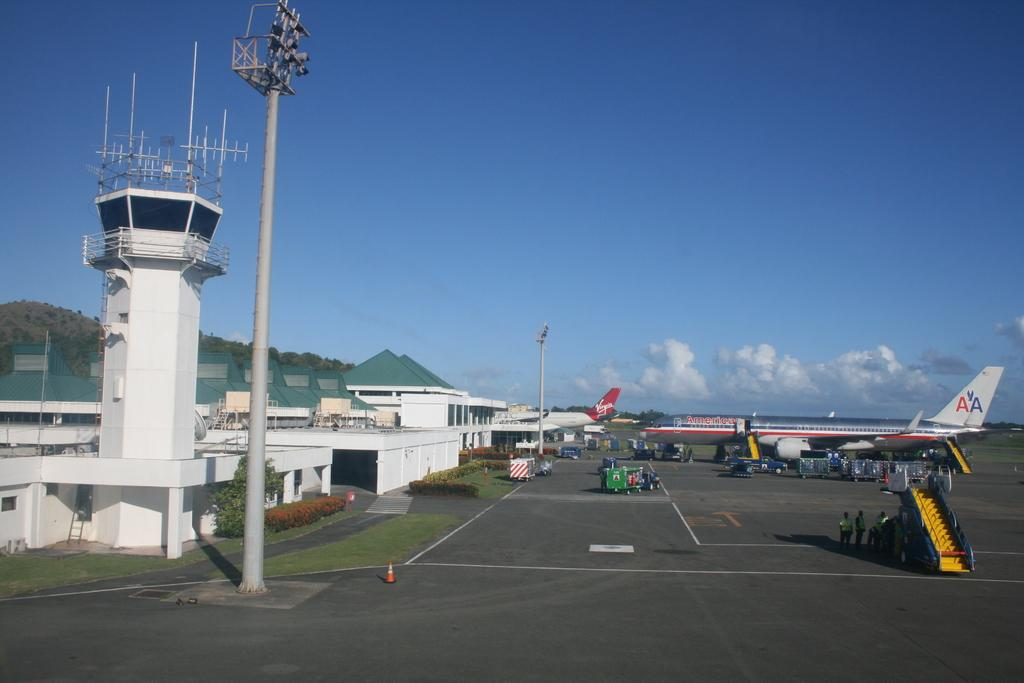<image>
Create a compact narrative representing the image presented. a virgin airlines plane sits in front of an american airlines plane 